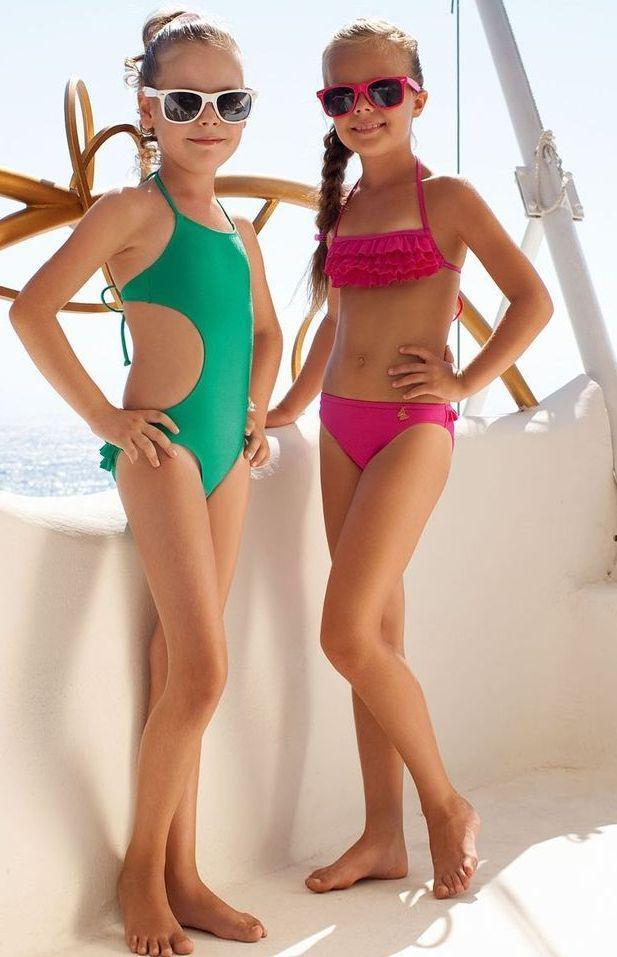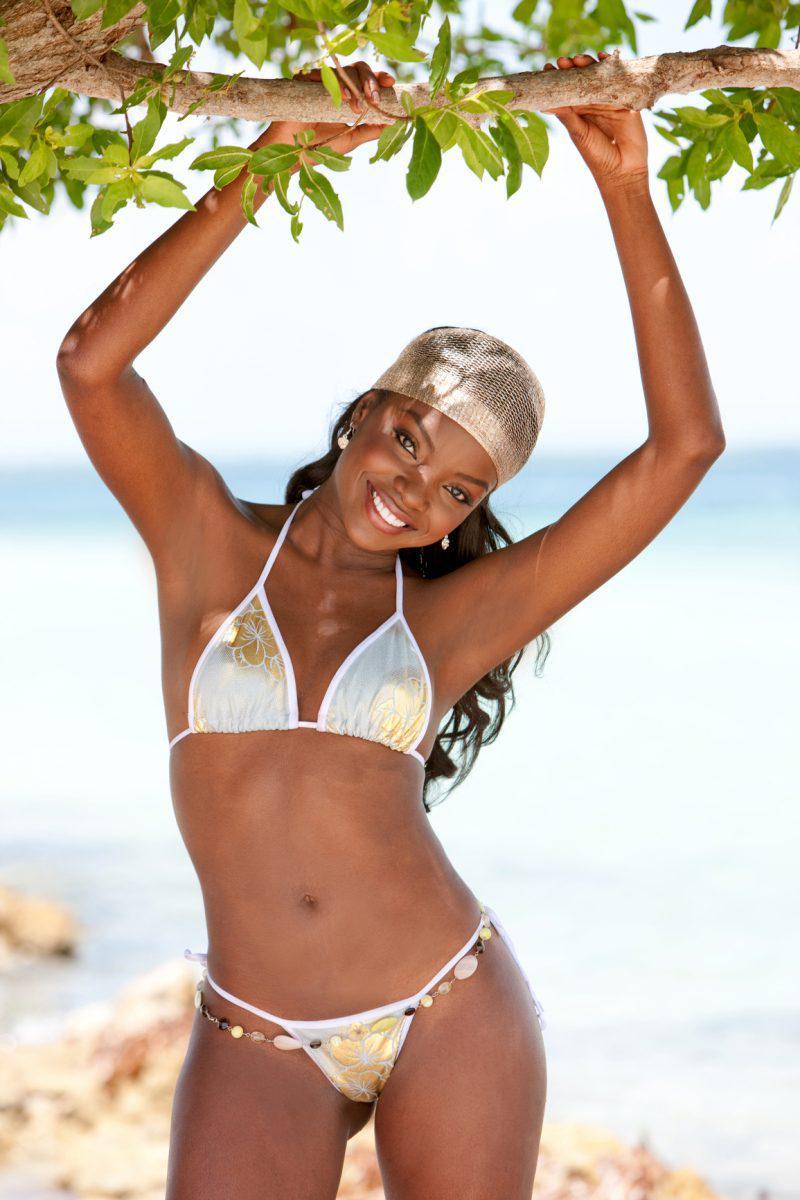The first image is the image on the left, the second image is the image on the right. Evaluate the accuracy of this statement regarding the images: "A striped bikini top is modeled in one image.". Is it true? Answer yes or no. No. The first image is the image on the left, the second image is the image on the right. For the images displayed, is the sentence "In the left image, a woman poses in a bikini on a sandy beach by herself" factually correct? Answer yes or no. No. 